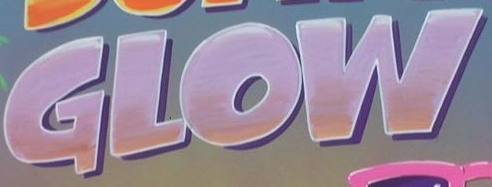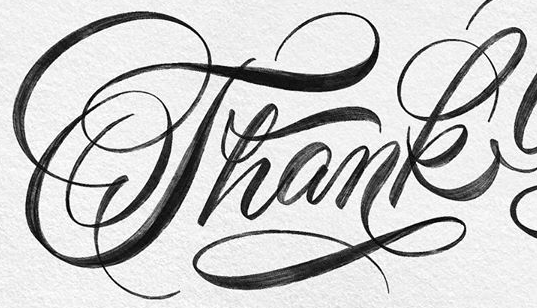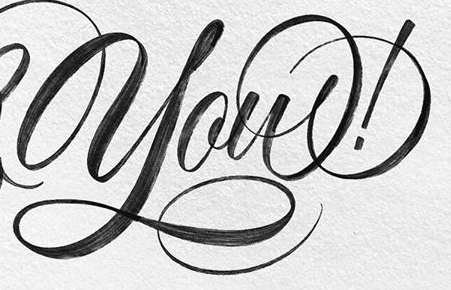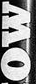Transcribe the words shown in these images in order, separated by a semicolon. GLOW; Thank; you!; MO 